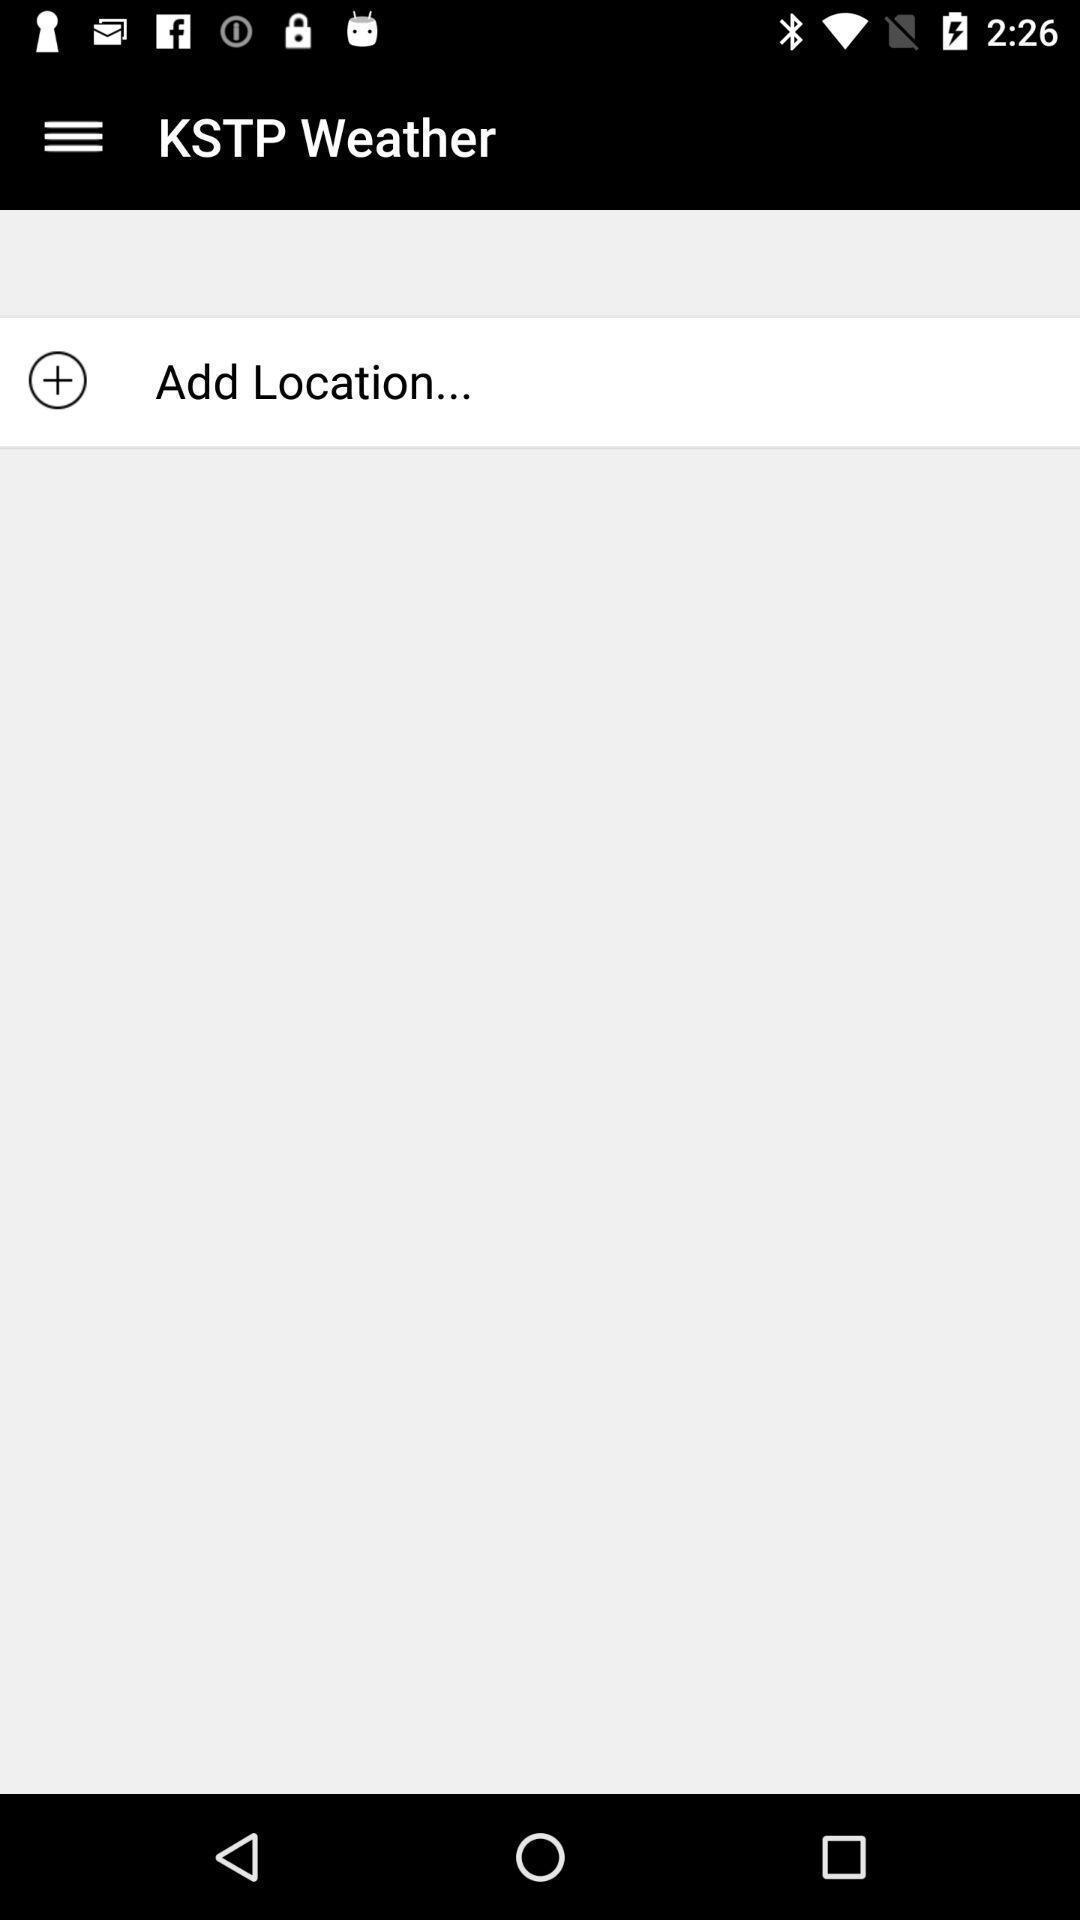Provide a textual representation of this image. Page for adding location of a weather app. 